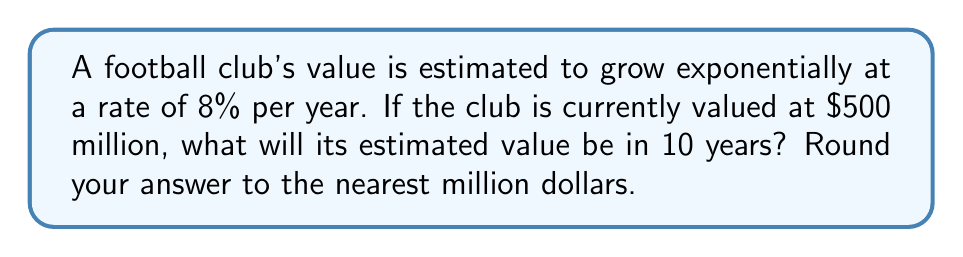Could you help me with this problem? To solve this problem, we'll use the exponential growth formula:

$$A = P(1 + r)^t$$

Where:
$A$ = Final amount
$P$ = Initial principal balance
$r$ = Annual growth rate (as a decimal)
$t$ = Time in years

Given:
$P = \$500$ million
$r = 8\% = 0.08$
$t = 10$ years

Step 1: Plug the values into the formula
$$A = 500(1 + 0.08)^{10}$$

Step 2: Simplify the expression inside the parentheses
$$A = 500(1.08)^{10}$$

Step 3: Calculate the exponential term
$$(1.08)^{10} \approx 2.1589$$

Step 4: Multiply by the initial value
$$A = 500 \times 2.1589 = 1079.45$$

Step 5: Round to the nearest million
$$A \approx \$1,079$ million

Therefore, the estimated value of the football club after 10 years will be approximately $1,079 million or $1.079 billion.
Answer: $1,079 million 